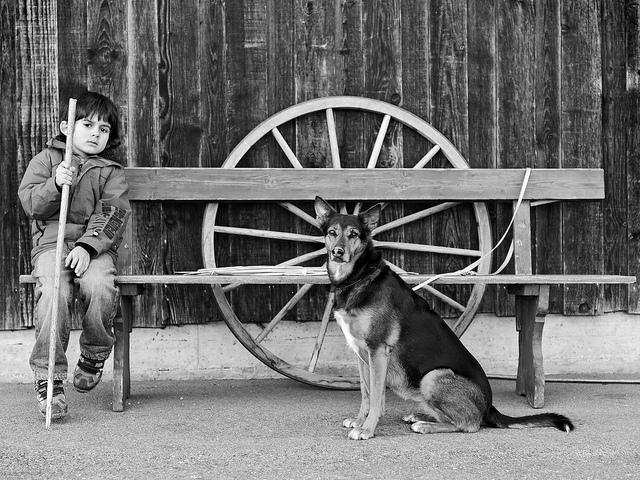What is the wheel called that's behind the bench?
Choose the correct response and explain in the format: 'Answer: answer
Rationale: rationale.'
Options: Train wheels, chariot wheels, artillery wheels, wagon wheel. Answer: wagon wheel.
Rationale: The wheel is built from a material and is of a size and composition consistent with answer a. 